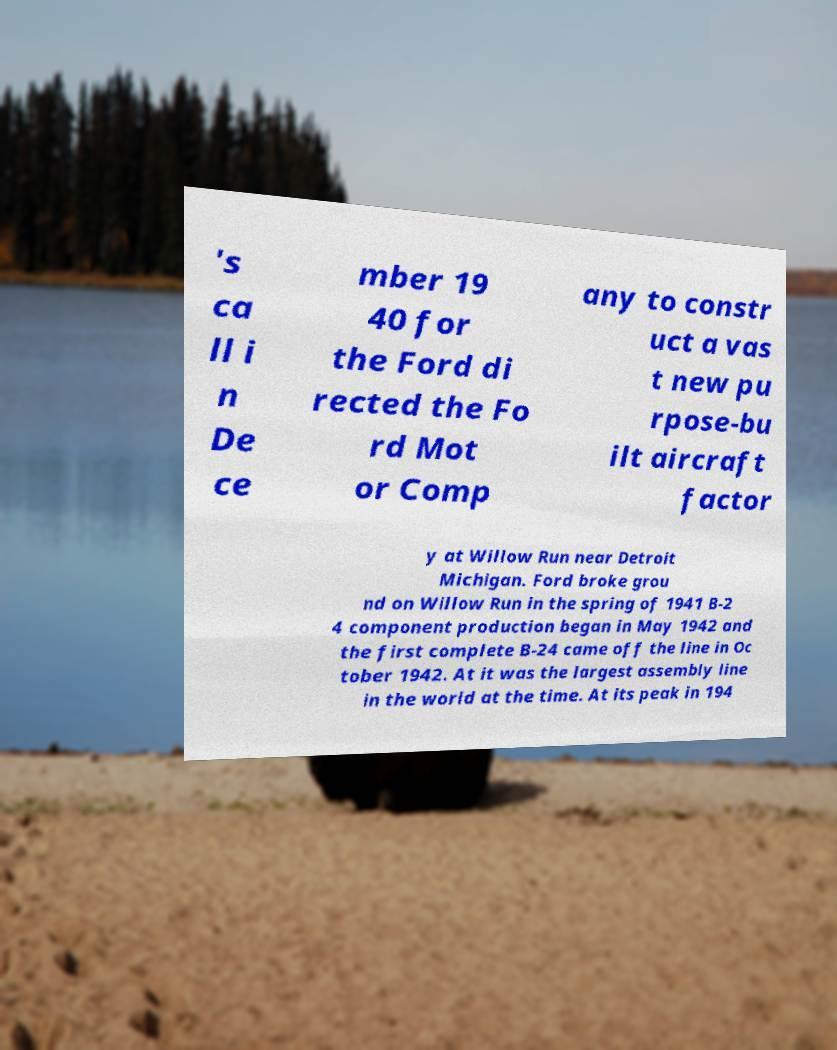I need the written content from this picture converted into text. Can you do that? 's ca ll i n De ce mber 19 40 for the Ford di rected the Fo rd Mot or Comp any to constr uct a vas t new pu rpose-bu ilt aircraft factor y at Willow Run near Detroit Michigan. Ford broke grou nd on Willow Run in the spring of 1941 B-2 4 component production began in May 1942 and the first complete B-24 came off the line in Oc tober 1942. At it was the largest assembly line in the world at the time. At its peak in 194 